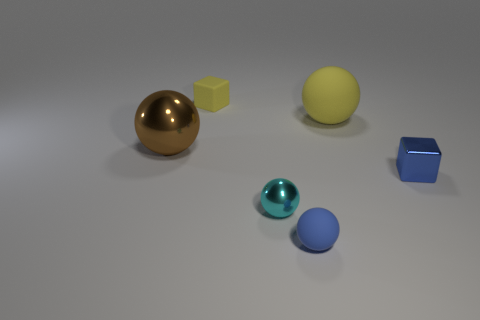What number of other things are the same shape as the cyan metal object?
Provide a short and direct response. 3. The cyan thing is what size?
Provide a short and direct response. Small. How big is the metallic object that is on the left side of the blue sphere and behind the cyan shiny object?
Keep it short and to the point. Large. What shape is the metallic object left of the tiny rubber block?
Your answer should be compact. Sphere. Do the yellow cube and the block that is on the right side of the small yellow rubber cube have the same material?
Ensure brevity in your answer.  No. Is the shape of the small cyan metal thing the same as the large yellow thing?
Offer a very short reply. Yes. What material is the other object that is the same shape as the small yellow object?
Provide a short and direct response. Metal. The small thing that is in front of the big yellow rubber ball and to the left of the tiny blue sphere is what color?
Your answer should be compact. Cyan. The large metallic sphere is what color?
Provide a short and direct response. Brown. What is the material of the tiny thing that is the same color as the tiny shiny block?
Your answer should be very brief. Rubber. 